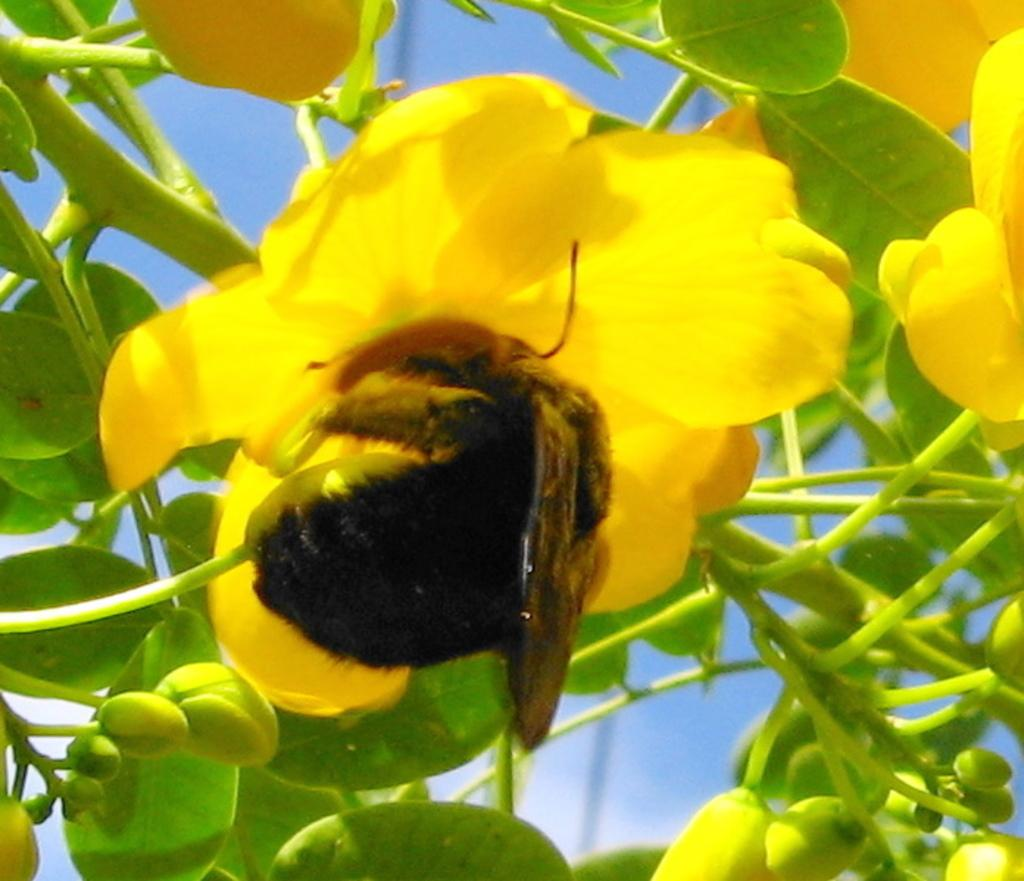What is the main subject in the center of the image? There is an insect in the center of the image. What can be seen in the background of the image? There is a plant, flowers, leaves, buds, and the sky visible in the background of the image. What type of jewel is the insect holding in the image? There is no jewel present in the image; it only features an insect and various elements in the background. 